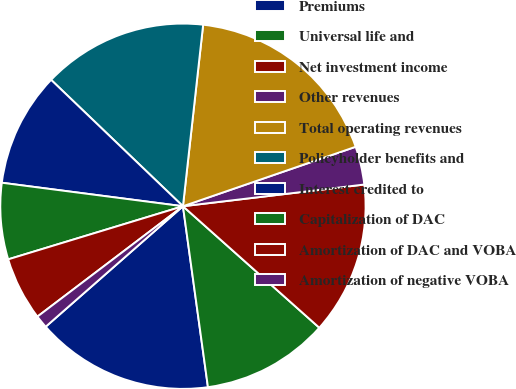<chart> <loc_0><loc_0><loc_500><loc_500><pie_chart><fcel>Premiums<fcel>Universal life and<fcel>Net investment income<fcel>Other revenues<fcel>Total operating revenues<fcel>Policyholder benefits and<fcel>Interest credited to<fcel>Capitalization of DAC<fcel>Amortization of DAC and VOBA<fcel>Amortization of negative VOBA<nl><fcel>15.72%<fcel>11.23%<fcel>13.48%<fcel>3.38%<fcel>17.96%<fcel>14.6%<fcel>10.11%<fcel>6.75%<fcel>5.63%<fcel>1.14%<nl></chart> 